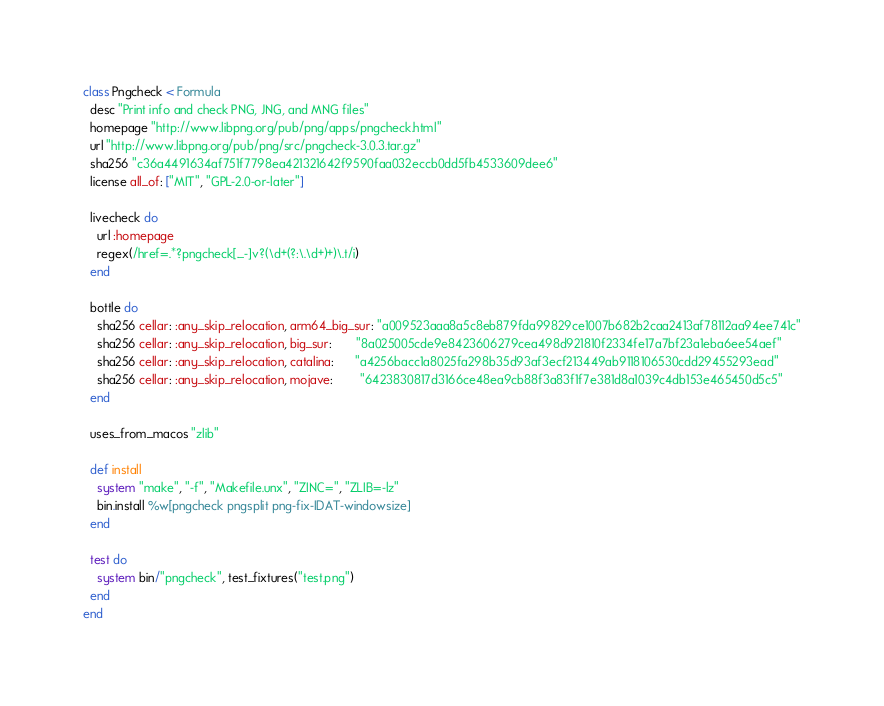Convert code to text. <code><loc_0><loc_0><loc_500><loc_500><_Ruby_>class Pngcheck < Formula
  desc "Print info and check PNG, JNG, and MNG files"
  homepage "http://www.libpng.org/pub/png/apps/pngcheck.html"
  url "http://www.libpng.org/pub/png/src/pngcheck-3.0.3.tar.gz"
  sha256 "c36a4491634af751f7798ea421321642f9590faa032eccb0dd5fb4533609dee6"
  license all_of: ["MIT", "GPL-2.0-or-later"]

  livecheck do
    url :homepage
    regex(/href=.*?pngcheck[._-]v?(\d+(?:\.\d+)+)\.t/i)
  end

  bottle do
    sha256 cellar: :any_skip_relocation, arm64_big_sur: "a009523aaa8a5c8eb879fda99829ce1007b682b2caa2413af78112aa94ee741c"
    sha256 cellar: :any_skip_relocation, big_sur:       "8a025005cde9e8423606279cea498d921810f2334fe17a7bf23a1eba6ee54aef"
    sha256 cellar: :any_skip_relocation, catalina:      "a4256bacc1a8025fa298b35d93af3ecf213449ab9118106530cdd29455293ead"
    sha256 cellar: :any_skip_relocation, mojave:        "6423830817d3166ce48ea9cb88f3a83f1f7e381d8a1039c4db153e465450d5c5"
  end

  uses_from_macos "zlib"

  def install
    system "make", "-f", "Makefile.unx", "ZINC=", "ZLIB=-lz"
    bin.install %w[pngcheck pngsplit png-fix-IDAT-windowsize]
  end

  test do
    system bin/"pngcheck", test_fixtures("test.png")
  end
end
</code> 